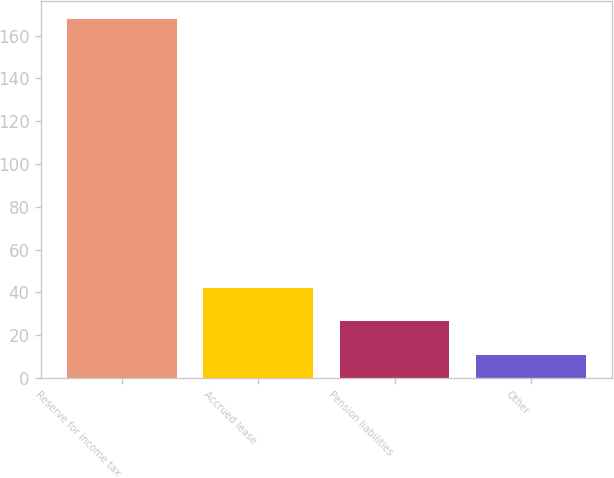<chart> <loc_0><loc_0><loc_500><loc_500><bar_chart><fcel>Reserve for income tax<fcel>Accrued lease<fcel>Pension liabilities<fcel>Other<nl><fcel>167.6<fcel>42.24<fcel>26.57<fcel>10.9<nl></chart> 